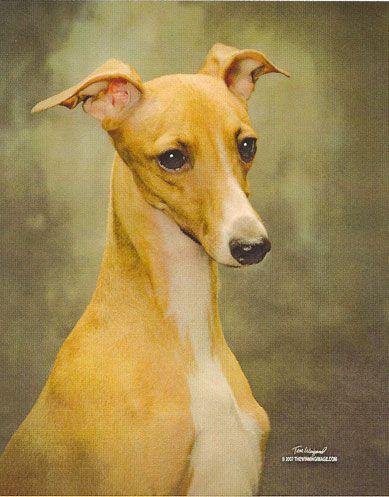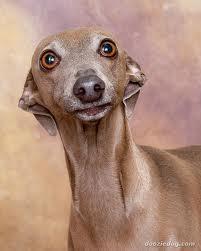The first image is the image on the left, the second image is the image on the right. Given the left and right images, does the statement "Two dogs are sitting together on a piece of furniture in the image on the left." hold true? Answer yes or no. No. The first image is the image on the left, the second image is the image on the right. For the images shown, is this caption "Each image features a single dog, and one dog looks rightward while the other is facing forward." true? Answer yes or no. Yes. 